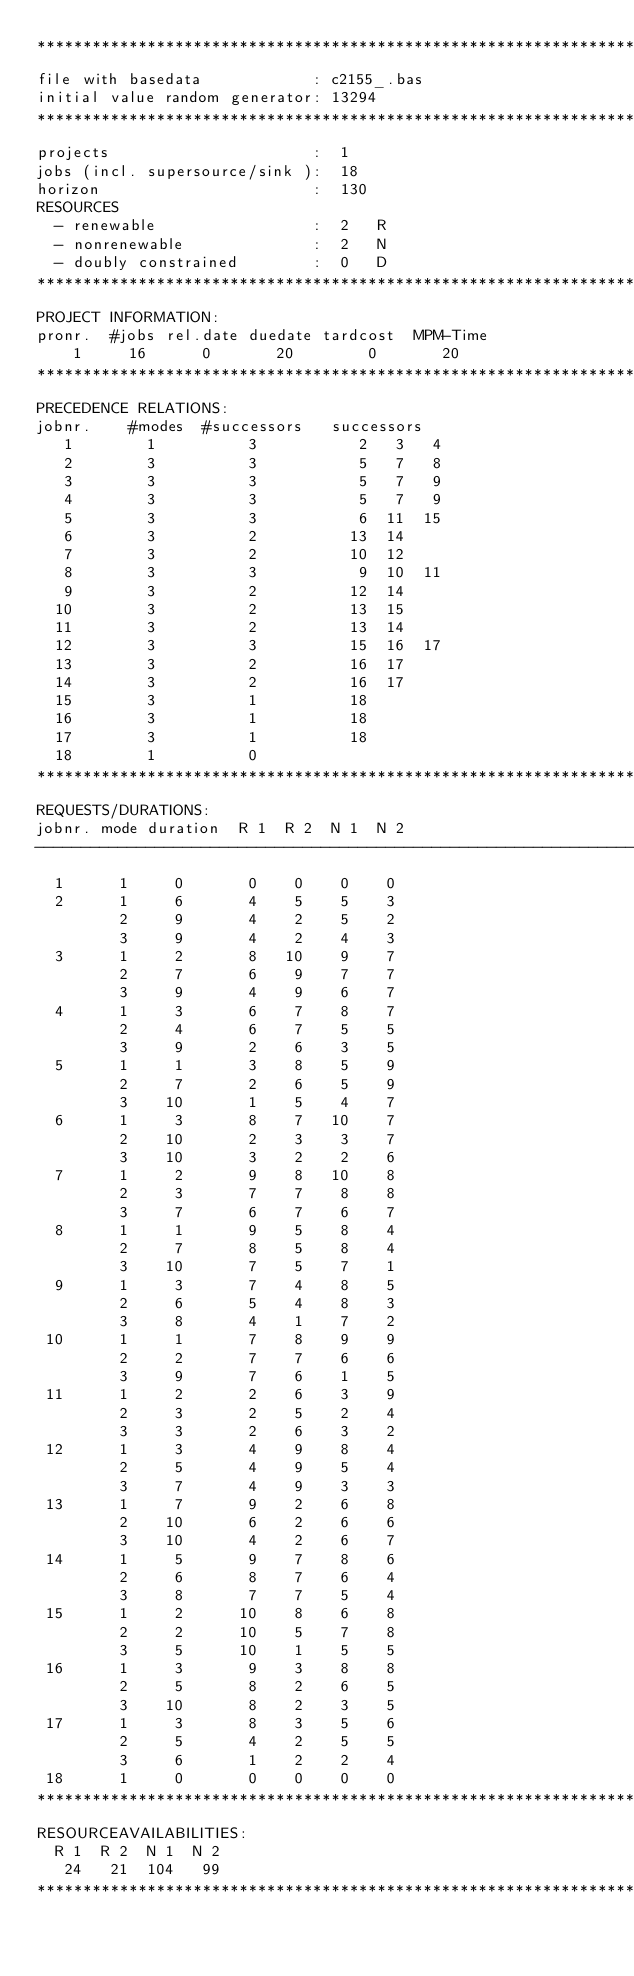Convert code to text. <code><loc_0><loc_0><loc_500><loc_500><_ObjectiveC_>************************************************************************
file with basedata            : c2155_.bas
initial value random generator: 13294
************************************************************************
projects                      :  1
jobs (incl. supersource/sink ):  18
horizon                       :  130
RESOURCES
  - renewable                 :  2   R
  - nonrenewable              :  2   N
  - doubly constrained        :  0   D
************************************************************************
PROJECT INFORMATION:
pronr.  #jobs rel.date duedate tardcost  MPM-Time
    1     16      0       20        0       20
************************************************************************
PRECEDENCE RELATIONS:
jobnr.    #modes  #successors   successors
   1        1          3           2   3   4
   2        3          3           5   7   8
   3        3          3           5   7   9
   4        3          3           5   7   9
   5        3          3           6  11  15
   6        3          2          13  14
   7        3          2          10  12
   8        3          3           9  10  11
   9        3          2          12  14
  10        3          2          13  15
  11        3          2          13  14
  12        3          3          15  16  17
  13        3          2          16  17
  14        3          2          16  17
  15        3          1          18
  16        3          1          18
  17        3          1          18
  18        1          0        
************************************************************************
REQUESTS/DURATIONS:
jobnr. mode duration  R 1  R 2  N 1  N 2
------------------------------------------------------------------------
  1      1     0       0    0    0    0
  2      1     6       4    5    5    3
         2     9       4    2    5    2
         3     9       4    2    4    3
  3      1     2       8   10    9    7
         2     7       6    9    7    7
         3     9       4    9    6    7
  4      1     3       6    7    8    7
         2     4       6    7    5    5
         3     9       2    6    3    5
  5      1     1       3    8    5    9
         2     7       2    6    5    9
         3    10       1    5    4    7
  6      1     3       8    7   10    7
         2    10       2    3    3    7
         3    10       3    2    2    6
  7      1     2       9    8   10    8
         2     3       7    7    8    8
         3     7       6    7    6    7
  8      1     1       9    5    8    4
         2     7       8    5    8    4
         3    10       7    5    7    1
  9      1     3       7    4    8    5
         2     6       5    4    8    3
         3     8       4    1    7    2
 10      1     1       7    8    9    9
         2     2       7    7    6    6
         3     9       7    6    1    5
 11      1     2       2    6    3    9
         2     3       2    5    2    4
         3     3       2    6    3    2
 12      1     3       4    9    8    4
         2     5       4    9    5    4
         3     7       4    9    3    3
 13      1     7       9    2    6    8
         2    10       6    2    6    6
         3    10       4    2    6    7
 14      1     5       9    7    8    6
         2     6       8    7    6    4
         3     8       7    7    5    4
 15      1     2      10    8    6    8
         2     2      10    5    7    8
         3     5      10    1    5    5
 16      1     3       9    3    8    8
         2     5       8    2    6    5
         3    10       8    2    3    5
 17      1     3       8    3    5    6
         2     5       4    2    5    5
         3     6       1    2    2    4
 18      1     0       0    0    0    0
************************************************************************
RESOURCEAVAILABILITIES:
  R 1  R 2  N 1  N 2
   24   21  104   99
************************************************************************
</code> 